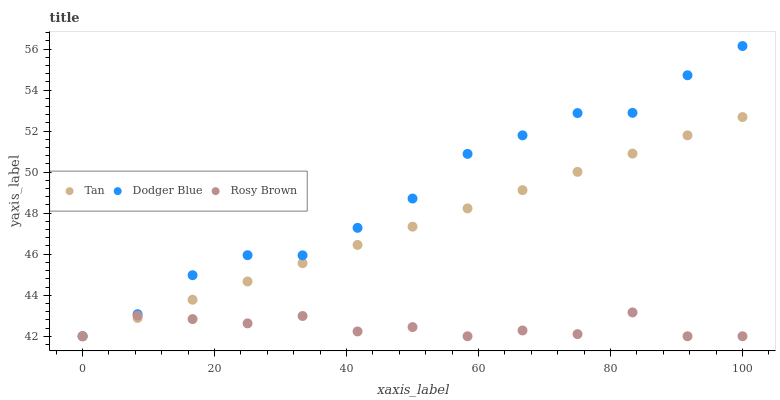Does Rosy Brown have the minimum area under the curve?
Answer yes or no. Yes. Does Dodger Blue have the maximum area under the curve?
Answer yes or no. Yes. Does Dodger Blue have the minimum area under the curve?
Answer yes or no. No. Does Rosy Brown have the maximum area under the curve?
Answer yes or no. No. Is Tan the smoothest?
Answer yes or no. Yes. Is Rosy Brown the roughest?
Answer yes or no. Yes. Is Dodger Blue the smoothest?
Answer yes or no. No. Is Dodger Blue the roughest?
Answer yes or no. No. Does Tan have the lowest value?
Answer yes or no. Yes. Does Dodger Blue have the highest value?
Answer yes or no. Yes. Does Rosy Brown have the highest value?
Answer yes or no. No. Does Tan intersect Dodger Blue?
Answer yes or no. Yes. Is Tan less than Dodger Blue?
Answer yes or no. No. Is Tan greater than Dodger Blue?
Answer yes or no. No. 